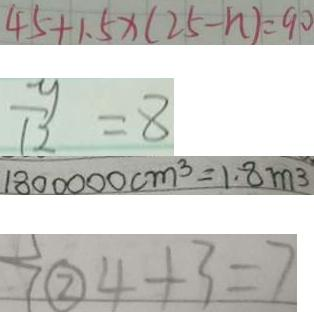Convert formula to latex. <formula><loc_0><loc_0><loc_500><loc_500>4 5 + 1 . 5 x ( 2 5 - n ) = 9 0 
 \frac { y } { 1 2 } = 8 
 1 8 0 0 0 0 0 c m ^ { 3 } = 1 . 8 m ^ { 3 } 
 \textcircled { 2 } 4 + 3 = 7</formula> 